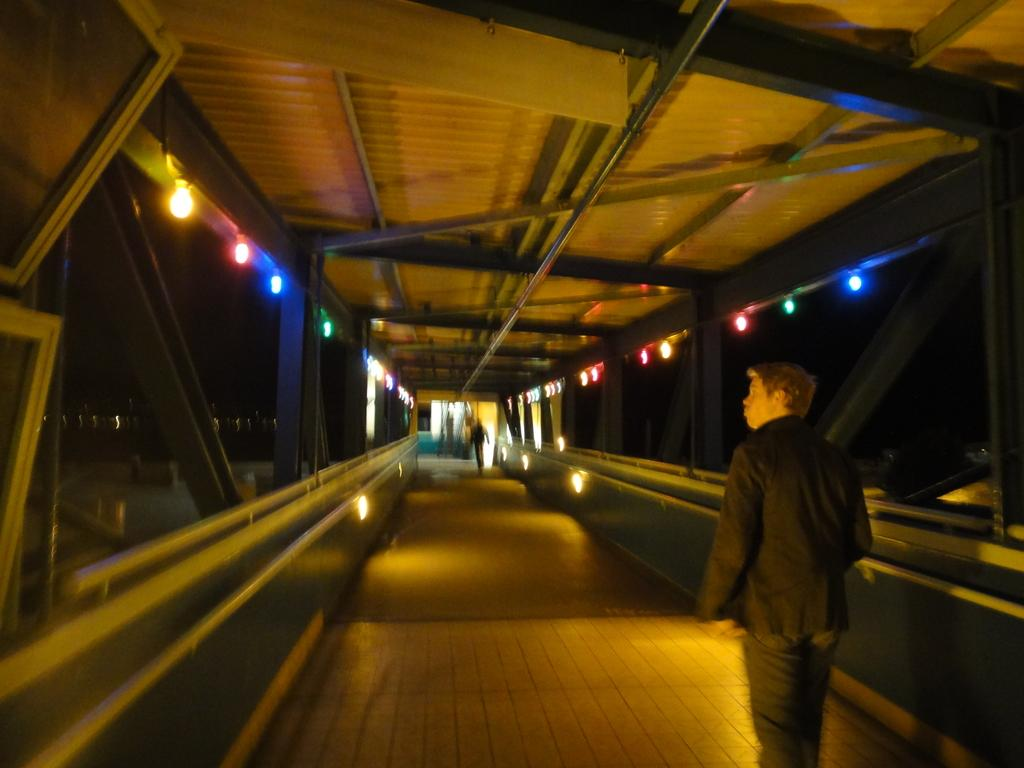What structure can be seen in the image? There is a bridge in the image. Are there any people present in the image? Yes, there are people in the image. What else can be seen in the image besides the bridge and people? There are lights visible in the image. What is located at the top of the image? There is a roof visible at the top of the image. What type of hair product is being advertised on the roof in the image? There is no hair product or advertisement present on the roof in the image. 